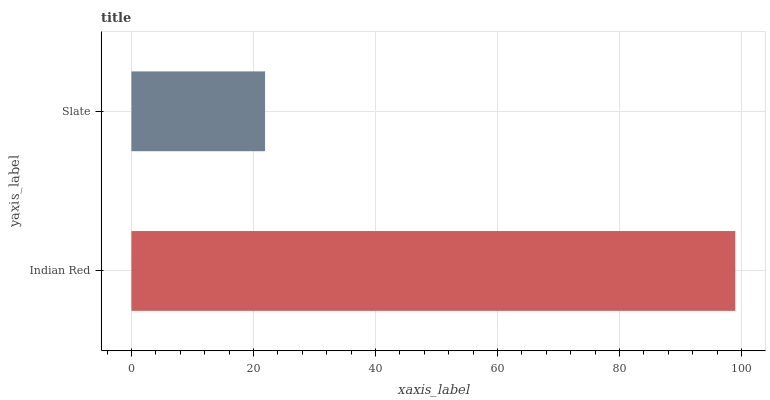Is Slate the minimum?
Answer yes or no. Yes. Is Indian Red the maximum?
Answer yes or no. Yes. Is Slate the maximum?
Answer yes or no. No. Is Indian Red greater than Slate?
Answer yes or no. Yes. Is Slate less than Indian Red?
Answer yes or no. Yes. Is Slate greater than Indian Red?
Answer yes or no. No. Is Indian Red less than Slate?
Answer yes or no. No. Is Indian Red the high median?
Answer yes or no. Yes. Is Slate the low median?
Answer yes or no. Yes. Is Slate the high median?
Answer yes or no. No. Is Indian Red the low median?
Answer yes or no. No. 